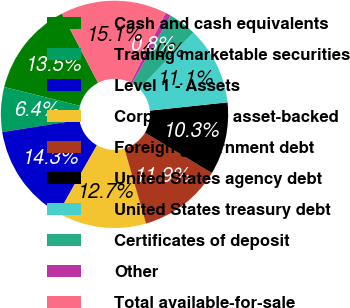Convert chart. <chart><loc_0><loc_0><loc_500><loc_500><pie_chart><fcel>Cash and cash equivalents<fcel>Trading marketable securities<fcel>Level 1 - Assets<fcel>Corporate and asset-backed<fcel>Foreign government debt<fcel>United States agency debt<fcel>United States treasury debt<fcel>Certificates of deposit<fcel>Other<fcel>Total available-for-sale<nl><fcel>13.49%<fcel>6.35%<fcel>14.28%<fcel>12.7%<fcel>11.9%<fcel>10.32%<fcel>11.11%<fcel>3.97%<fcel>0.8%<fcel>15.08%<nl></chart> 